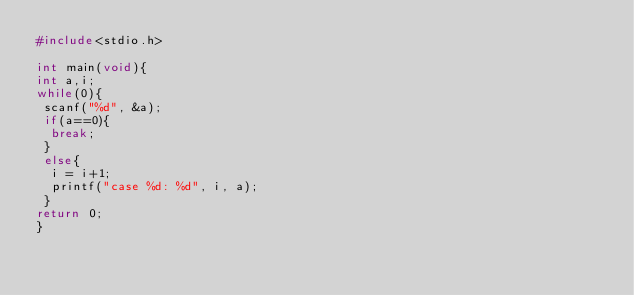Convert code to text. <code><loc_0><loc_0><loc_500><loc_500><_C_>#include<stdio.h>
 
int main(void){
int a,i;
while(0){
 scanf("%d", &a);
 if(a==0){
  break;
 }
 else{
  i = i+1;
  printf("case %d: %d", i, a);
 }
return 0;
}</code> 